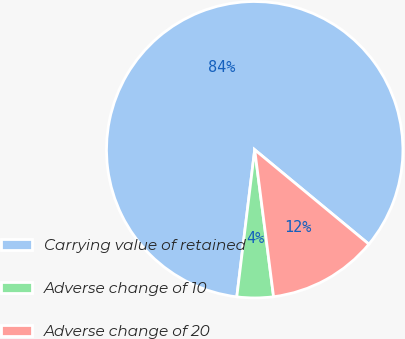Convert chart to OTSL. <chart><loc_0><loc_0><loc_500><loc_500><pie_chart><fcel>Carrying value of retained<fcel>Adverse change of 10<fcel>Adverse change of 20<nl><fcel>84.07%<fcel>3.96%<fcel>11.97%<nl></chart> 